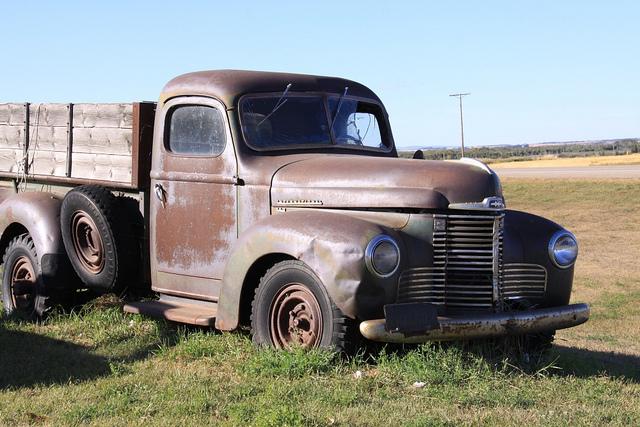How long has the truck been there?
Quick response, please. Long time. What model is the truck?
Keep it brief. Ford. What color is the truck?
Keep it brief. Brown. 